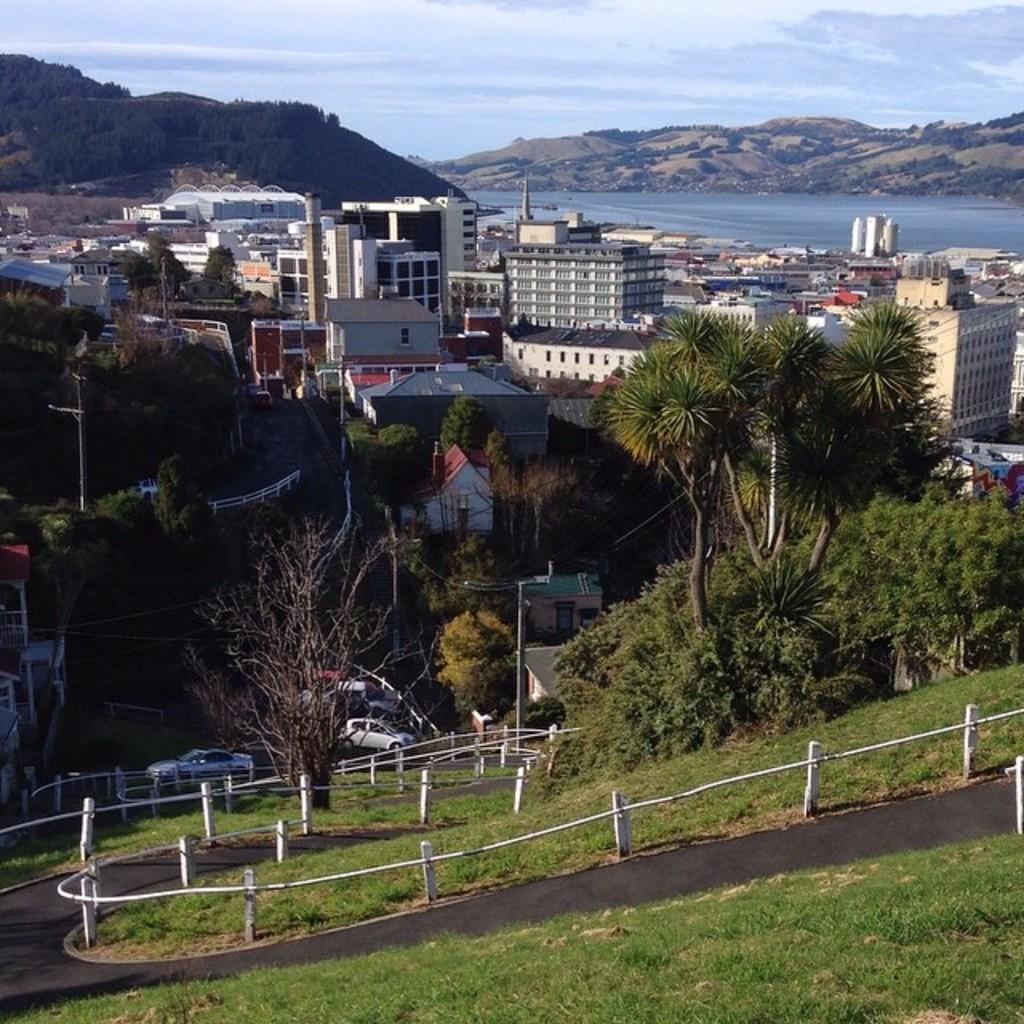Describe this image in one or two sentences. In this image I can see the road, the railing, some grass on the ground, few trees and few vehicles on the road. In the background I can see few buildings, few mountains, the water and the sky. 